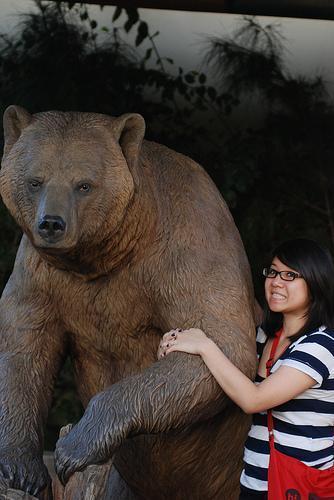How many people are in the picture?
Give a very brief answer. 1. How many bear statues are there?
Give a very brief answer. 1. 